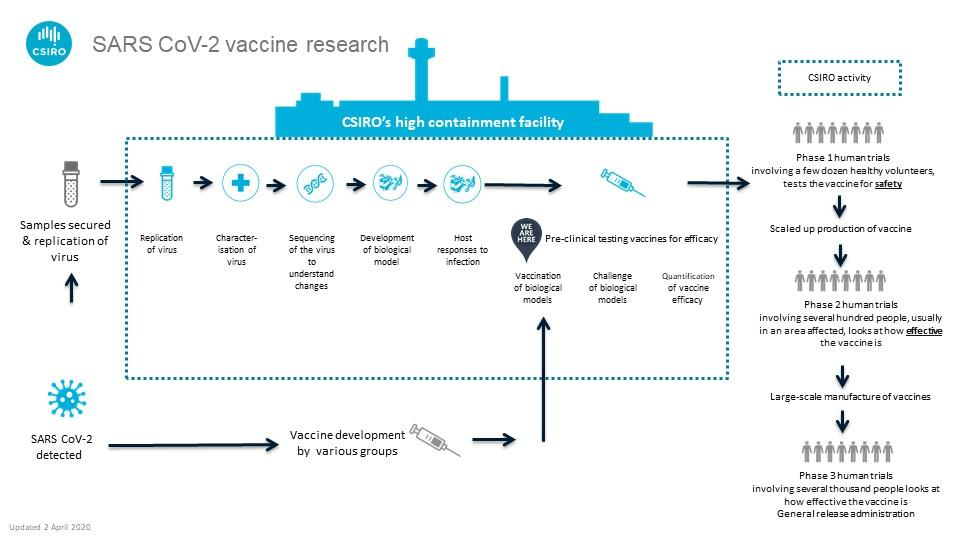Draw attention to some important aspects in this diagram. There are two needles in the infographic. The infographic contains two test tubes. 